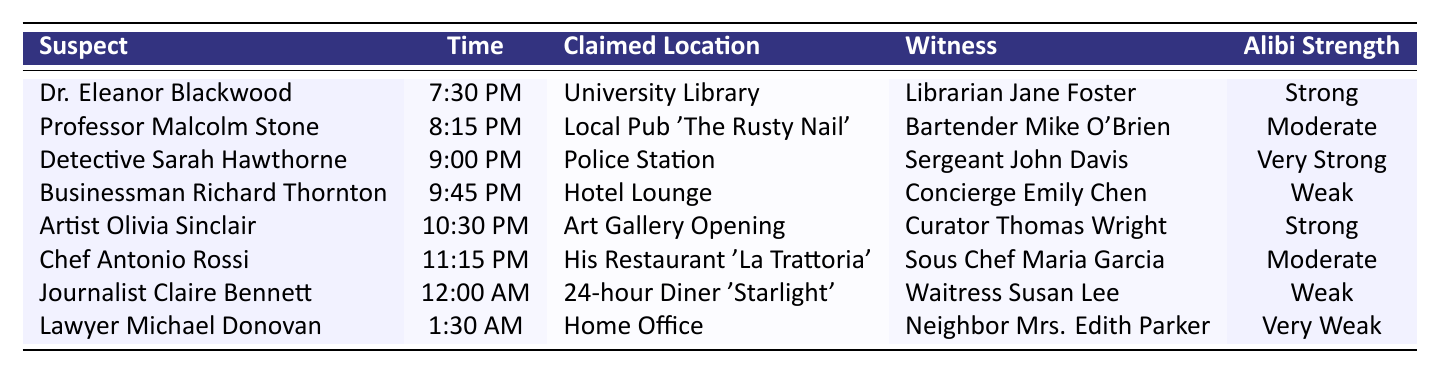What time did Dr. Eleanor Blackwood claim to be at the University Library? According to the table, Dr. Eleanor Blackwood claimed to be at the University Library at 7:30 PM.
Answer: 7:30 PM Which suspect has the weakest alibi? The table shows that Lawyer Michael Donovan has the weakest alibi strength, classified as "Very Weak."
Answer: Lawyer Michael Donovan How many suspects have an alibi strength considered moderate? From the table, we see that there are two suspects with a moderate alibi strength: Professor Malcolm Stone and Chef Antonio Rossi.
Answer: 2 What is the claimed location of Detective Sarah Hawthorne during the 9:00 PM time slot? The table indicates that Detective Sarah Hawthorne claimed to be at the Police Station at 9:00 PM.
Answer: Police Station Is there any suspect whose witness is not a professional in their field? By examining the table, we find that Lawyer Michael Donovan's witness, Mrs. Edith Parker, is a neighbor rather than a professional witness, thus the answer is yes.
Answer: Yes What is the time difference between the earliest and latest alibi claims? The earliest claim is at 7:30 PM (Dr. Eleanor Blackwood) and the latest is at 1:30 AM (Lawyer Michael Donovan). The time difference is 6 hours.
Answer: 6 hours Which suspect has an alibi strength classified as very strong and what is their claimed location? Looking at the table, Detective Sarah Hawthorne has an alibi strength classified as "Very Strong" and claims to be at the Police Station.
Answer: Detective Sarah Hawthorne, Police Station Compare the number of suspects with strong alibi strength to those with weak alibi strength. In the table, there are three suspects with a strong alibi strength (Dr. Eleanor Blackwood, Artist Olivia Sinclair, and Detective Sarah Hawthorne) and three with a weak strength (Businessman Richard Thornton, Journalist Claire Bennett, and Lawyer Michael Donovan). Thus, they are tied.
Answer: Tied (3 each) Which location is the most commonly claimed among the suspects? Analyzing the claimed locations in the table, we see that each location is unique to a suspect, so no location is repeated.
Answer: None (All unique) If we categorize alibi strengths as strong (strong and very strong) and weak (weak and very weak), how many suspects fall into each category? The table indicates that there are 5 suspects with strong alibis (Dr. Eleanor Blackwood, Detective Sarah Hawthorne, Artist Olivia Sinclair) and 4 with weak alibis (Businessman Richard Thornton, Journalist Claire Bennett, Lawyer Michael Donovan).
Answer: Strong: 5, Weak: 4 